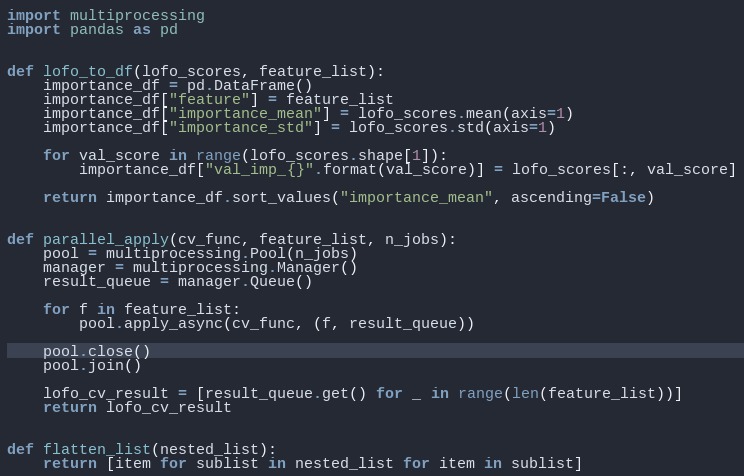<code> <loc_0><loc_0><loc_500><loc_500><_Python_>import multiprocessing
import pandas as pd


def lofo_to_df(lofo_scores, feature_list):
    importance_df = pd.DataFrame()
    importance_df["feature"] = feature_list
    importance_df["importance_mean"] = lofo_scores.mean(axis=1)
    importance_df["importance_std"] = lofo_scores.std(axis=1)

    for val_score in range(lofo_scores.shape[1]):
        importance_df["val_imp_{}".format(val_score)] = lofo_scores[:, val_score]

    return importance_df.sort_values("importance_mean", ascending=False)


def parallel_apply(cv_func, feature_list, n_jobs):
    pool = multiprocessing.Pool(n_jobs)
    manager = multiprocessing.Manager()
    result_queue = manager.Queue()

    for f in feature_list:
        pool.apply_async(cv_func, (f, result_queue))

    pool.close()
    pool.join()

    lofo_cv_result = [result_queue.get() for _ in range(len(feature_list))]
    return lofo_cv_result


def flatten_list(nested_list):
    return [item for sublist in nested_list for item in sublist]
</code> 